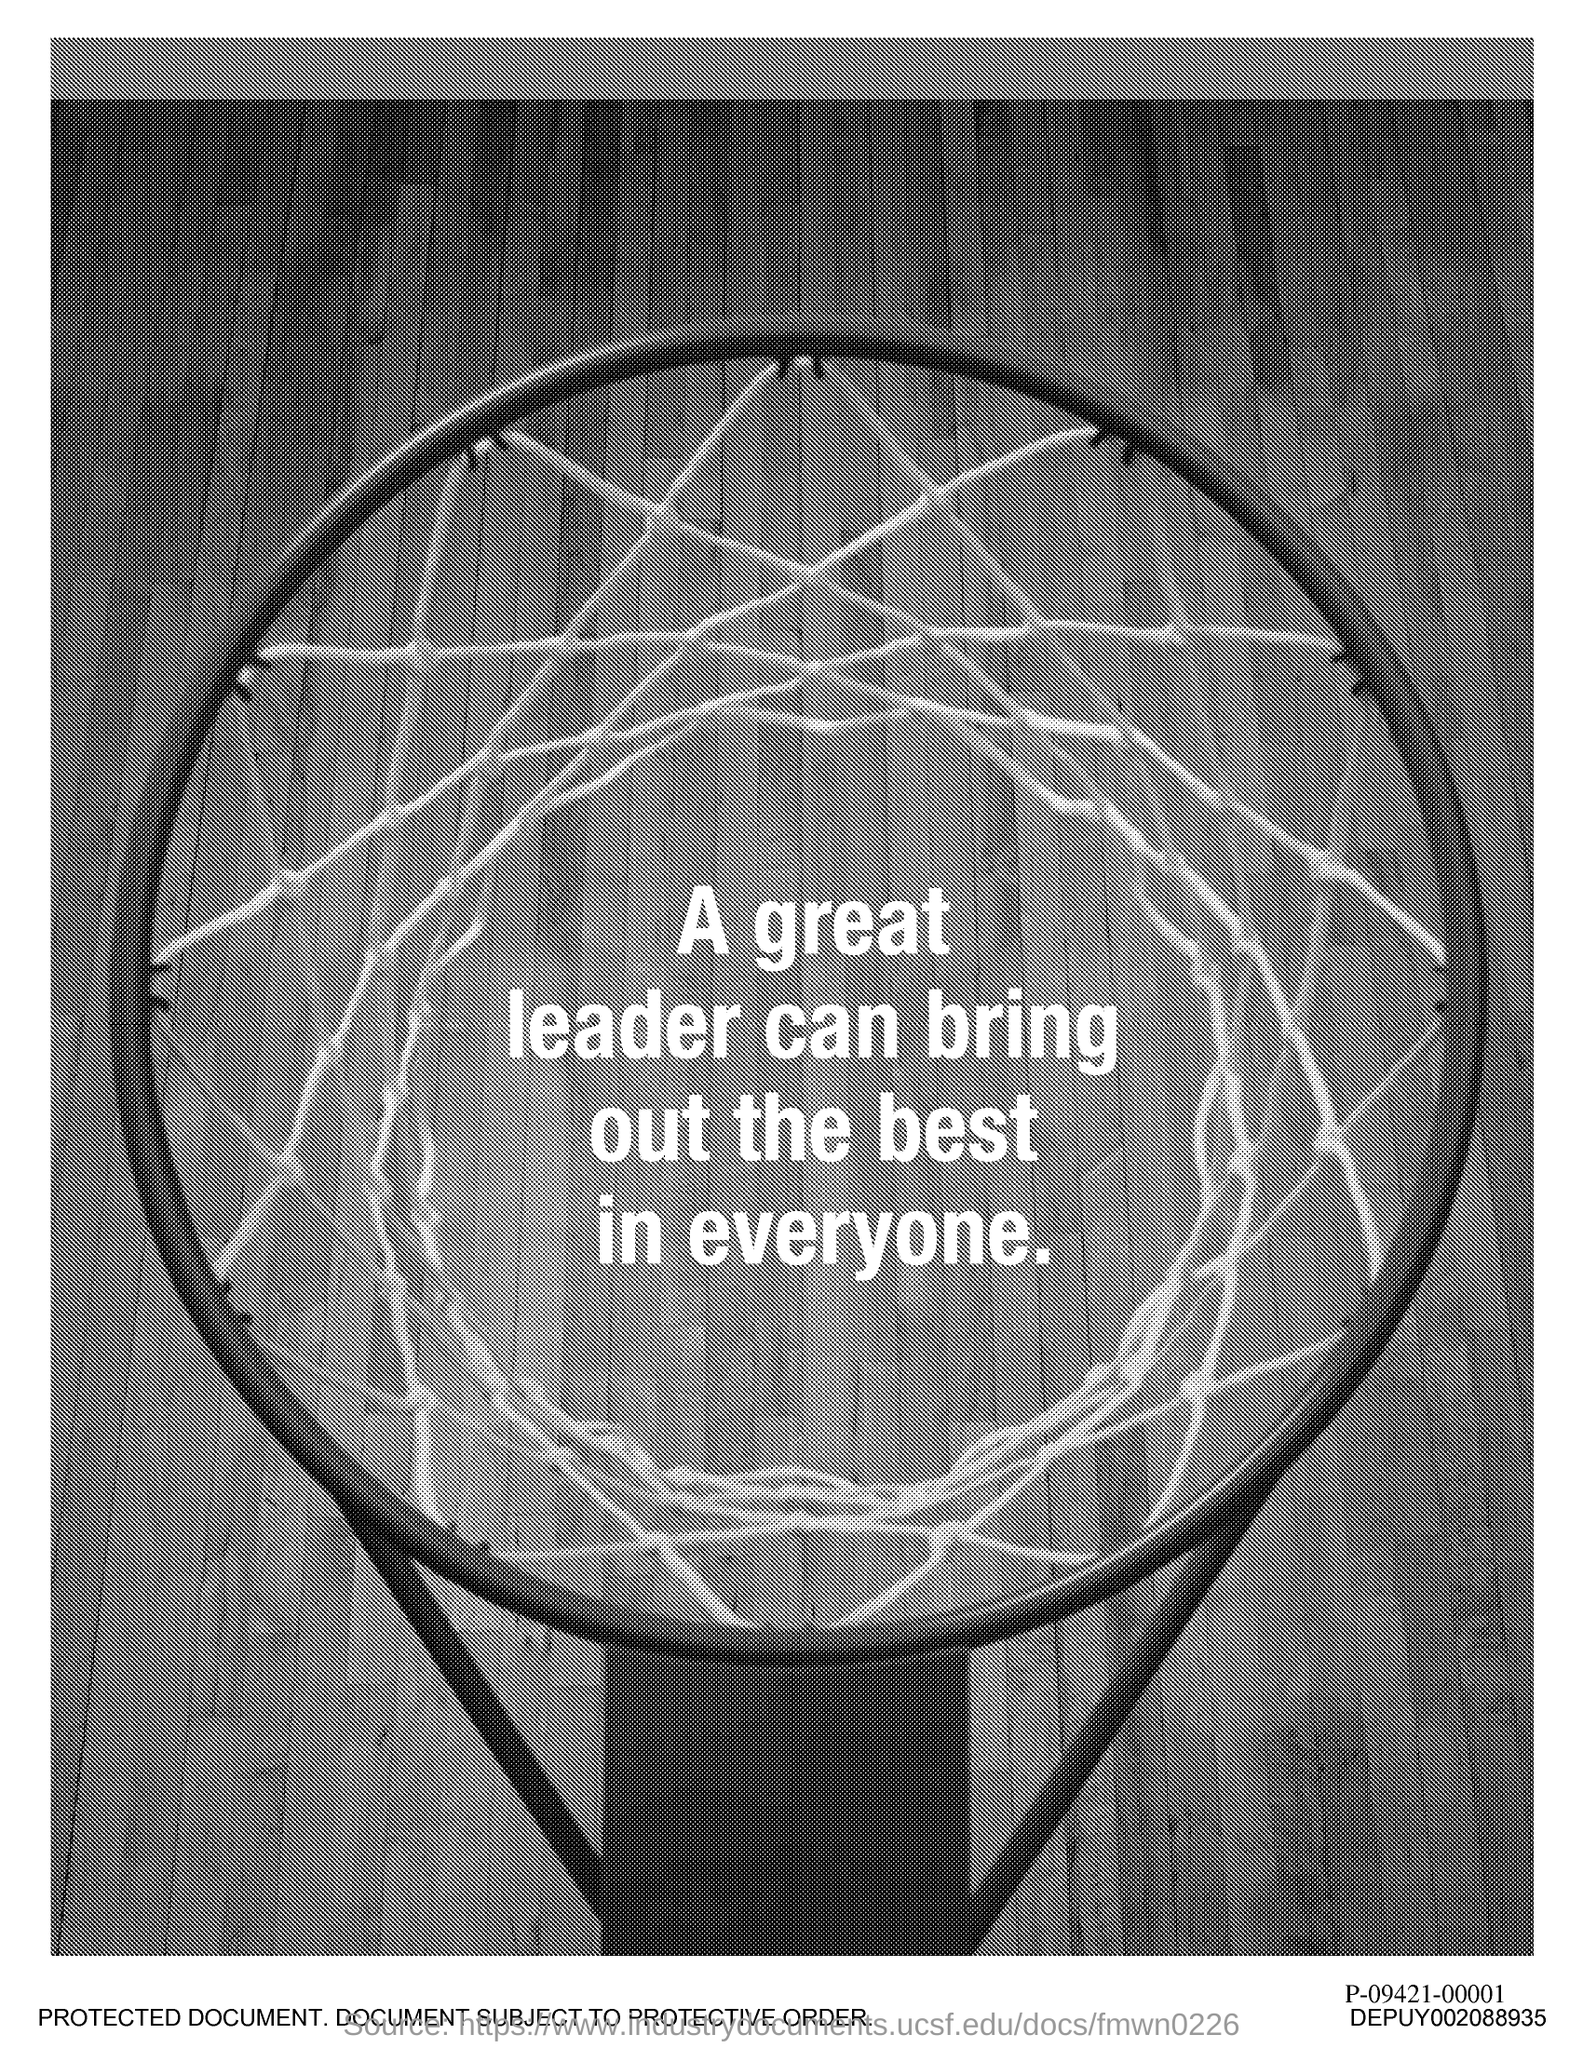Who can bring out the best in everyone?
Your answer should be very brief. A great leader. What does a great leader bring out?
Give a very brief answer. The best in everyone. 